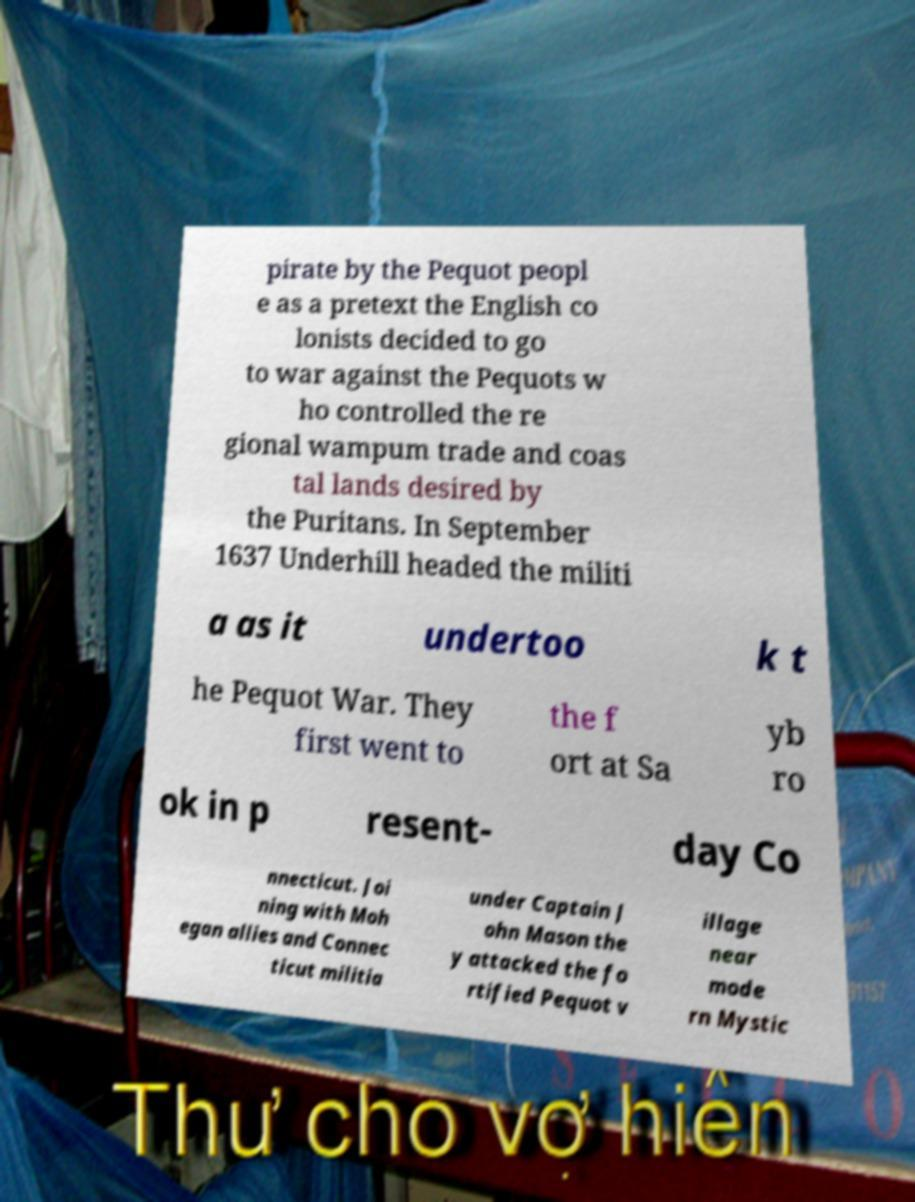Could you assist in decoding the text presented in this image and type it out clearly? pirate by the Pequot peopl e as a pretext the English co lonists decided to go to war against the Pequots w ho controlled the re gional wampum trade and coas tal lands desired by the Puritans. In September 1637 Underhill headed the militi a as it undertoo k t he Pequot War. They first went to the f ort at Sa yb ro ok in p resent- day Co nnecticut. Joi ning with Moh egan allies and Connec ticut militia under Captain J ohn Mason the y attacked the fo rtified Pequot v illage near mode rn Mystic 